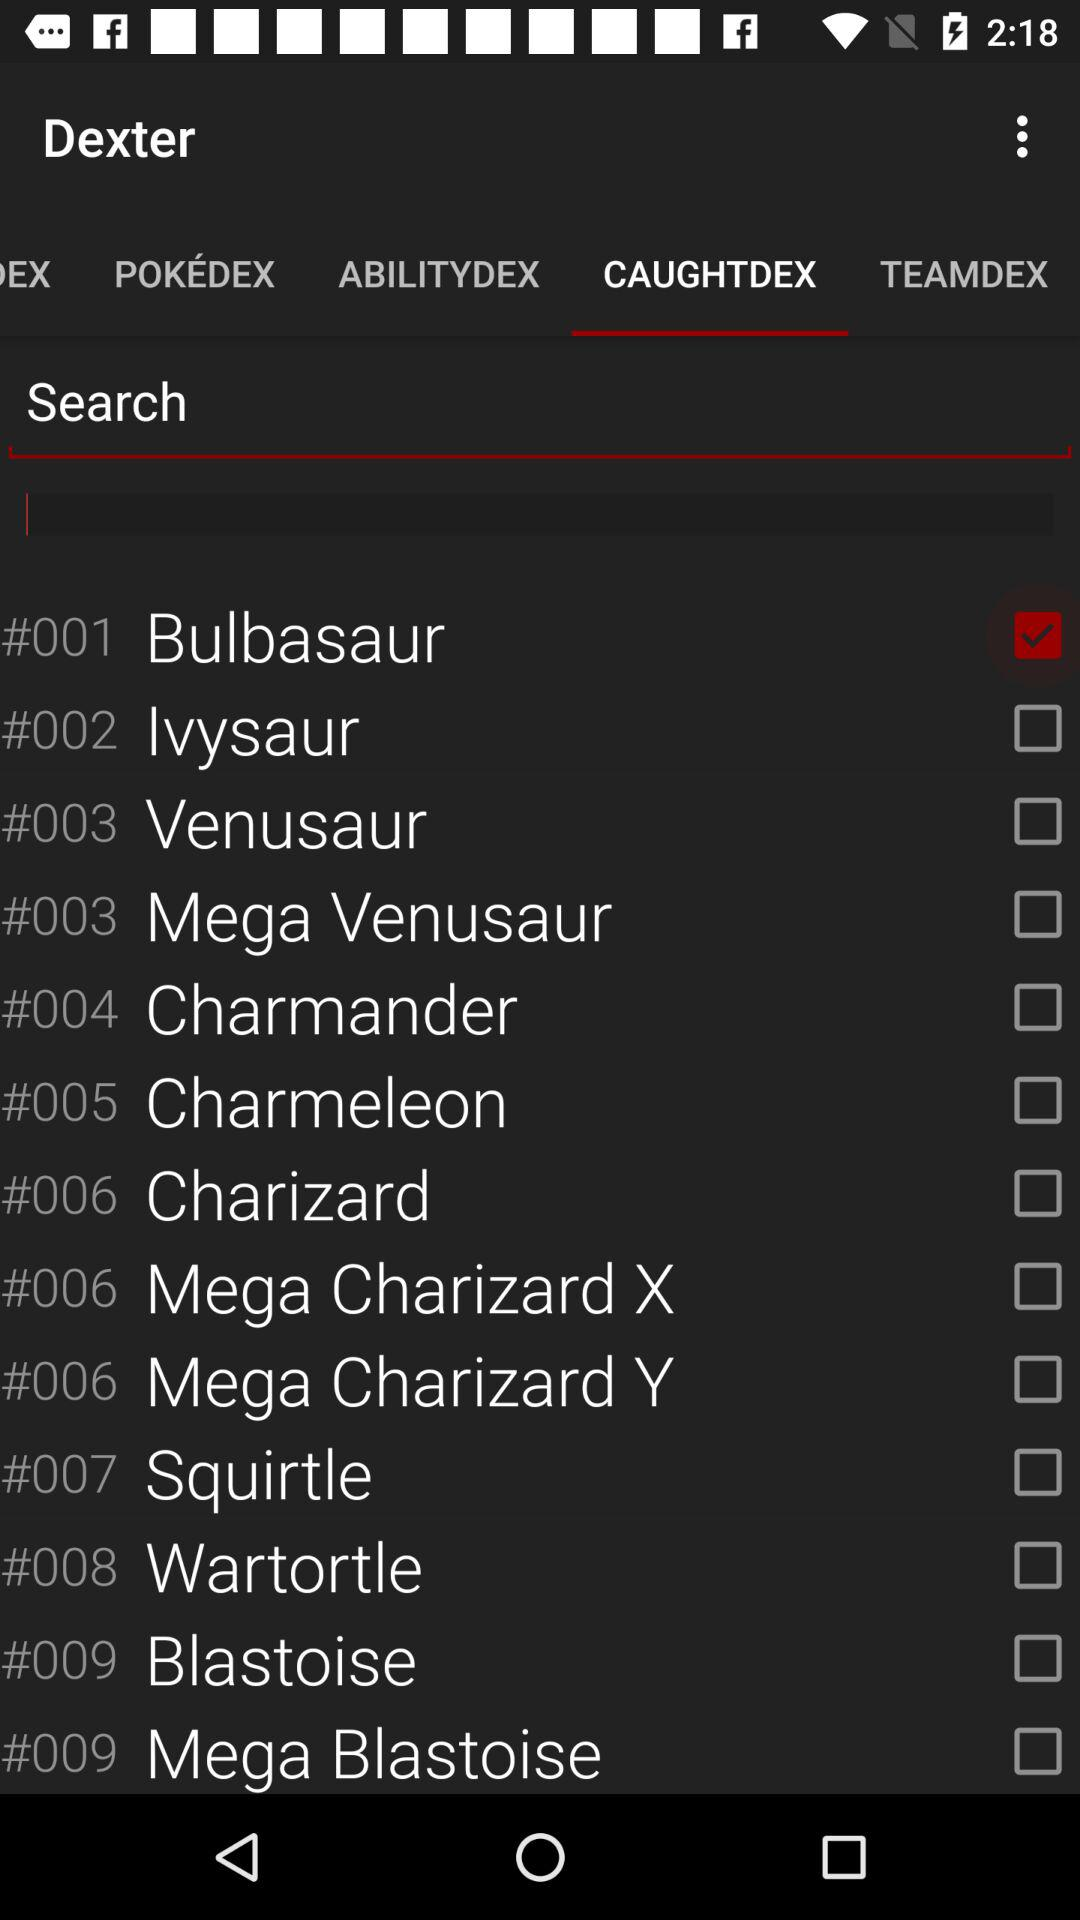What is the status of the "Squirtle"? The status is off. 